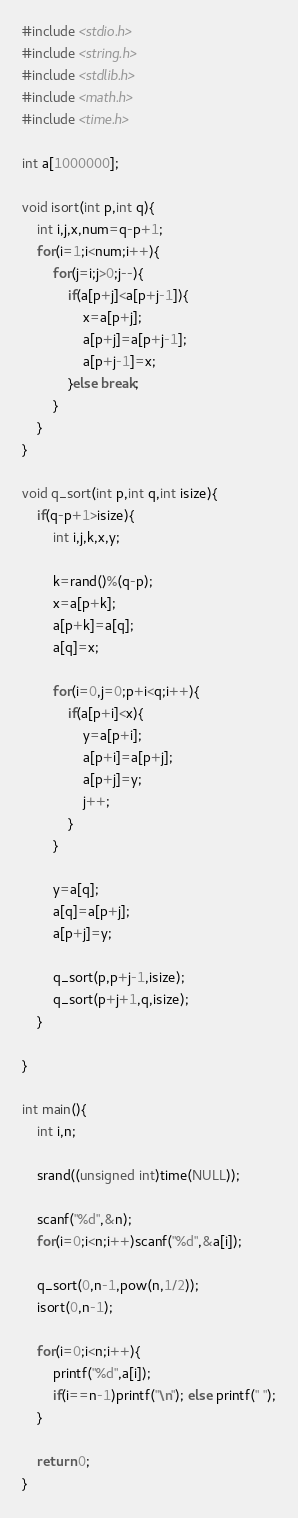<code> <loc_0><loc_0><loc_500><loc_500><_C_>#include <stdio.h>
#include <string.h>
#include <stdlib.h>
#include <math.h>
#include <time.h>

int a[1000000];

void isort(int p,int q){
	int i,j,x,num=q-p+1;
	for(i=1;i<num;i++){
		for(j=i;j>0;j--){
			if(a[p+j]<a[p+j-1]){
				x=a[p+j];
				a[p+j]=a[p+j-1];
				a[p+j-1]=x;
			}else break;
		}
	}
}

void q_sort(int p,int q,int isize){
    if(q-p+1>isize){
        int i,j,k,x,y;
		
        k=rand()%(q-p);
        x=a[p+k];
        a[p+k]=a[q];
        a[q]=x;
		
        for(i=0,j=0;p+i<q;i++){
            if(a[p+i]<x){
                y=a[p+i];
                a[p+i]=a[p+j];
                a[p+j]=y;
                j++;
            }
        }
		
        y=a[q];
        a[q]=a[p+j];
        a[p+j]=y;
		
		q_sort(p,p+j-1,isize);
        q_sort(p+j+1,q,isize);
    }
	
}

int main(){
    int i,n;
	
    srand((unsigned int)time(NULL));
	
    scanf("%d",&n);
    for(i=0;i<n;i++)scanf("%d",&a[i]);
	
    q_sort(0,n-1,pow(n,1/2));
	isort(0,n-1);
	
    for(i=0;i<n;i++){
        printf("%d",a[i]);
        if(i==n-1)printf("\n"); else printf(" ");
    }
	
    return 0;
}</code> 